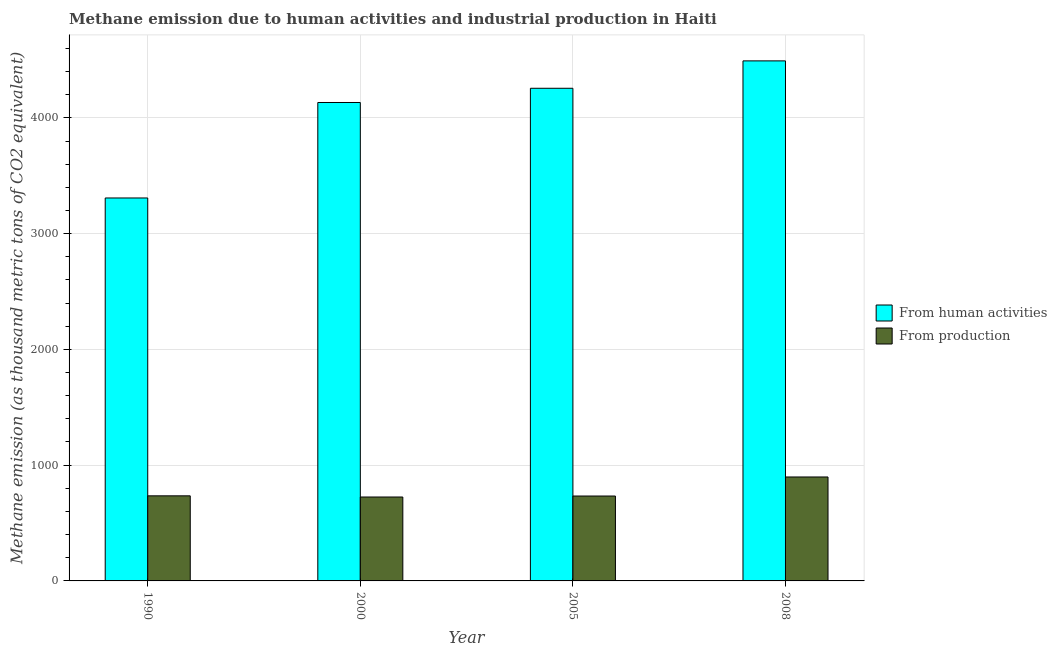Are the number of bars per tick equal to the number of legend labels?
Offer a very short reply. Yes. How many bars are there on the 1st tick from the left?
Provide a short and direct response. 2. What is the label of the 3rd group of bars from the left?
Make the answer very short. 2005. In how many cases, is the number of bars for a given year not equal to the number of legend labels?
Make the answer very short. 0. What is the amount of emissions from human activities in 2000?
Your response must be concise. 4132.6. Across all years, what is the maximum amount of emissions generated from industries?
Provide a succinct answer. 897.9. Across all years, what is the minimum amount of emissions from human activities?
Make the answer very short. 3307.8. In which year was the amount of emissions generated from industries maximum?
Keep it short and to the point. 2008. What is the total amount of emissions generated from industries in the graph?
Keep it short and to the point. 3091. What is the difference between the amount of emissions from human activities in 2005 and that in 2008?
Make the answer very short. -236.7. What is the difference between the amount of emissions from human activities in 2000 and the amount of emissions generated from industries in 2008?
Your answer should be compact. -359.5. What is the average amount of emissions from human activities per year?
Your answer should be very brief. 4046.97. What is the ratio of the amount of emissions from human activities in 1990 to that in 2000?
Provide a short and direct response. 0.8. Is the amount of emissions from human activities in 2005 less than that in 2008?
Ensure brevity in your answer.  Yes. What is the difference between the highest and the second highest amount of emissions generated from industries?
Give a very brief answer. 163. What is the difference between the highest and the lowest amount of emissions from human activities?
Your answer should be compact. 1184.3. In how many years, is the amount of emissions generated from industries greater than the average amount of emissions generated from industries taken over all years?
Your answer should be very brief. 1. Is the sum of the amount of emissions from human activities in 2000 and 2005 greater than the maximum amount of emissions generated from industries across all years?
Give a very brief answer. Yes. What does the 1st bar from the left in 2000 represents?
Offer a very short reply. From human activities. What does the 2nd bar from the right in 2008 represents?
Provide a succinct answer. From human activities. Are all the bars in the graph horizontal?
Make the answer very short. No. How many years are there in the graph?
Provide a short and direct response. 4. What is the difference between two consecutive major ticks on the Y-axis?
Keep it short and to the point. 1000. Does the graph contain grids?
Give a very brief answer. Yes. Where does the legend appear in the graph?
Offer a very short reply. Center right. What is the title of the graph?
Make the answer very short. Methane emission due to human activities and industrial production in Haiti. What is the label or title of the Y-axis?
Offer a very short reply. Methane emission (as thousand metric tons of CO2 equivalent). What is the Methane emission (as thousand metric tons of CO2 equivalent) in From human activities in 1990?
Your answer should be very brief. 3307.8. What is the Methane emission (as thousand metric tons of CO2 equivalent) in From production in 1990?
Offer a terse response. 734.9. What is the Methane emission (as thousand metric tons of CO2 equivalent) in From human activities in 2000?
Keep it short and to the point. 4132.6. What is the Methane emission (as thousand metric tons of CO2 equivalent) of From production in 2000?
Your response must be concise. 724.8. What is the Methane emission (as thousand metric tons of CO2 equivalent) in From human activities in 2005?
Provide a short and direct response. 4255.4. What is the Methane emission (as thousand metric tons of CO2 equivalent) of From production in 2005?
Your response must be concise. 733.4. What is the Methane emission (as thousand metric tons of CO2 equivalent) of From human activities in 2008?
Offer a very short reply. 4492.1. What is the Methane emission (as thousand metric tons of CO2 equivalent) in From production in 2008?
Provide a short and direct response. 897.9. Across all years, what is the maximum Methane emission (as thousand metric tons of CO2 equivalent) in From human activities?
Offer a terse response. 4492.1. Across all years, what is the maximum Methane emission (as thousand metric tons of CO2 equivalent) of From production?
Your response must be concise. 897.9. Across all years, what is the minimum Methane emission (as thousand metric tons of CO2 equivalent) of From human activities?
Your response must be concise. 3307.8. Across all years, what is the minimum Methane emission (as thousand metric tons of CO2 equivalent) in From production?
Give a very brief answer. 724.8. What is the total Methane emission (as thousand metric tons of CO2 equivalent) of From human activities in the graph?
Ensure brevity in your answer.  1.62e+04. What is the total Methane emission (as thousand metric tons of CO2 equivalent) of From production in the graph?
Give a very brief answer. 3091. What is the difference between the Methane emission (as thousand metric tons of CO2 equivalent) of From human activities in 1990 and that in 2000?
Your response must be concise. -824.8. What is the difference between the Methane emission (as thousand metric tons of CO2 equivalent) in From production in 1990 and that in 2000?
Your answer should be compact. 10.1. What is the difference between the Methane emission (as thousand metric tons of CO2 equivalent) of From human activities in 1990 and that in 2005?
Ensure brevity in your answer.  -947.6. What is the difference between the Methane emission (as thousand metric tons of CO2 equivalent) of From human activities in 1990 and that in 2008?
Provide a succinct answer. -1184.3. What is the difference between the Methane emission (as thousand metric tons of CO2 equivalent) in From production in 1990 and that in 2008?
Your response must be concise. -163. What is the difference between the Methane emission (as thousand metric tons of CO2 equivalent) in From human activities in 2000 and that in 2005?
Ensure brevity in your answer.  -122.8. What is the difference between the Methane emission (as thousand metric tons of CO2 equivalent) of From production in 2000 and that in 2005?
Offer a terse response. -8.6. What is the difference between the Methane emission (as thousand metric tons of CO2 equivalent) in From human activities in 2000 and that in 2008?
Your response must be concise. -359.5. What is the difference between the Methane emission (as thousand metric tons of CO2 equivalent) of From production in 2000 and that in 2008?
Give a very brief answer. -173.1. What is the difference between the Methane emission (as thousand metric tons of CO2 equivalent) in From human activities in 2005 and that in 2008?
Make the answer very short. -236.7. What is the difference between the Methane emission (as thousand metric tons of CO2 equivalent) in From production in 2005 and that in 2008?
Make the answer very short. -164.5. What is the difference between the Methane emission (as thousand metric tons of CO2 equivalent) of From human activities in 1990 and the Methane emission (as thousand metric tons of CO2 equivalent) of From production in 2000?
Provide a short and direct response. 2583. What is the difference between the Methane emission (as thousand metric tons of CO2 equivalent) of From human activities in 1990 and the Methane emission (as thousand metric tons of CO2 equivalent) of From production in 2005?
Offer a very short reply. 2574.4. What is the difference between the Methane emission (as thousand metric tons of CO2 equivalent) of From human activities in 1990 and the Methane emission (as thousand metric tons of CO2 equivalent) of From production in 2008?
Your response must be concise. 2409.9. What is the difference between the Methane emission (as thousand metric tons of CO2 equivalent) in From human activities in 2000 and the Methane emission (as thousand metric tons of CO2 equivalent) in From production in 2005?
Provide a short and direct response. 3399.2. What is the difference between the Methane emission (as thousand metric tons of CO2 equivalent) in From human activities in 2000 and the Methane emission (as thousand metric tons of CO2 equivalent) in From production in 2008?
Offer a terse response. 3234.7. What is the difference between the Methane emission (as thousand metric tons of CO2 equivalent) of From human activities in 2005 and the Methane emission (as thousand metric tons of CO2 equivalent) of From production in 2008?
Offer a terse response. 3357.5. What is the average Methane emission (as thousand metric tons of CO2 equivalent) of From human activities per year?
Your answer should be very brief. 4046.97. What is the average Methane emission (as thousand metric tons of CO2 equivalent) in From production per year?
Offer a terse response. 772.75. In the year 1990, what is the difference between the Methane emission (as thousand metric tons of CO2 equivalent) in From human activities and Methane emission (as thousand metric tons of CO2 equivalent) in From production?
Offer a terse response. 2572.9. In the year 2000, what is the difference between the Methane emission (as thousand metric tons of CO2 equivalent) of From human activities and Methane emission (as thousand metric tons of CO2 equivalent) of From production?
Offer a very short reply. 3407.8. In the year 2005, what is the difference between the Methane emission (as thousand metric tons of CO2 equivalent) of From human activities and Methane emission (as thousand metric tons of CO2 equivalent) of From production?
Provide a succinct answer. 3522. In the year 2008, what is the difference between the Methane emission (as thousand metric tons of CO2 equivalent) in From human activities and Methane emission (as thousand metric tons of CO2 equivalent) in From production?
Your answer should be compact. 3594.2. What is the ratio of the Methane emission (as thousand metric tons of CO2 equivalent) in From human activities in 1990 to that in 2000?
Offer a very short reply. 0.8. What is the ratio of the Methane emission (as thousand metric tons of CO2 equivalent) in From production in 1990 to that in 2000?
Offer a very short reply. 1.01. What is the ratio of the Methane emission (as thousand metric tons of CO2 equivalent) of From human activities in 1990 to that in 2005?
Offer a very short reply. 0.78. What is the ratio of the Methane emission (as thousand metric tons of CO2 equivalent) in From production in 1990 to that in 2005?
Keep it short and to the point. 1. What is the ratio of the Methane emission (as thousand metric tons of CO2 equivalent) in From human activities in 1990 to that in 2008?
Provide a short and direct response. 0.74. What is the ratio of the Methane emission (as thousand metric tons of CO2 equivalent) of From production in 1990 to that in 2008?
Offer a very short reply. 0.82. What is the ratio of the Methane emission (as thousand metric tons of CO2 equivalent) of From human activities in 2000 to that in 2005?
Give a very brief answer. 0.97. What is the ratio of the Methane emission (as thousand metric tons of CO2 equivalent) in From production in 2000 to that in 2005?
Keep it short and to the point. 0.99. What is the ratio of the Methane emission (as thousand metric tons of CO2 equivalent) of From human activities in 2000 to that in 2008?
Provide a short and direct response. 0.92. What is the ratio of the Methane emission (as thousand metric tons of CO2 equivalent) in From production in 2000 to that in 2008?
Make the answer very short. 0.81. What is the ratio of the Methane emission (as thousand metric tons of CO2 equivalent) of From human activities in 2005 to that in 2008?
Provide a short and direct response. 0.95. What is the ratio of the Methane emission (as thousand metric tons of CO2 equivalent) in From production in 2005 to that in 2008?
Offer a very short reply. 0.82. What is the difference between the highest and the second highest Methane emission (as thousand metric tons of CO2 equivalent) of From human activities?
Make the answer very short. 236.7. What is the difference between the highest and the second highest Methane emission (as thousand metric tons of CO2 equivalent) of From production?
Provide a short and direct response. 163. What is the difference between the highest and the lowest Methane emission (as thousand metric tons of CO2 equivalent) in From human activities?
Provide a short and direct response. 1184.3. What is the difference between the highest and the lowest Methane emission (as thousand metric tons of CO2 equivalent) of From production?
Your answer should be very brief. 173.1. 